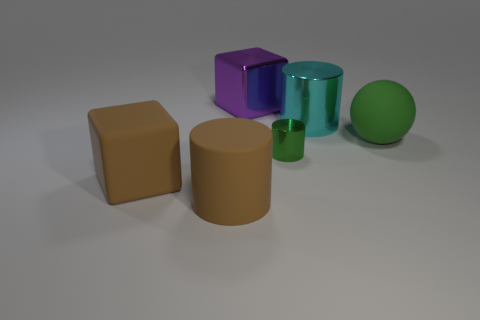Can you describe the lighting in the image? The lighting in the image seems to be soft and diffused, coming from above as indicated by the gentle shadows beneath the objects, which suggest an ambient or overhead light source without harsh direct light. 